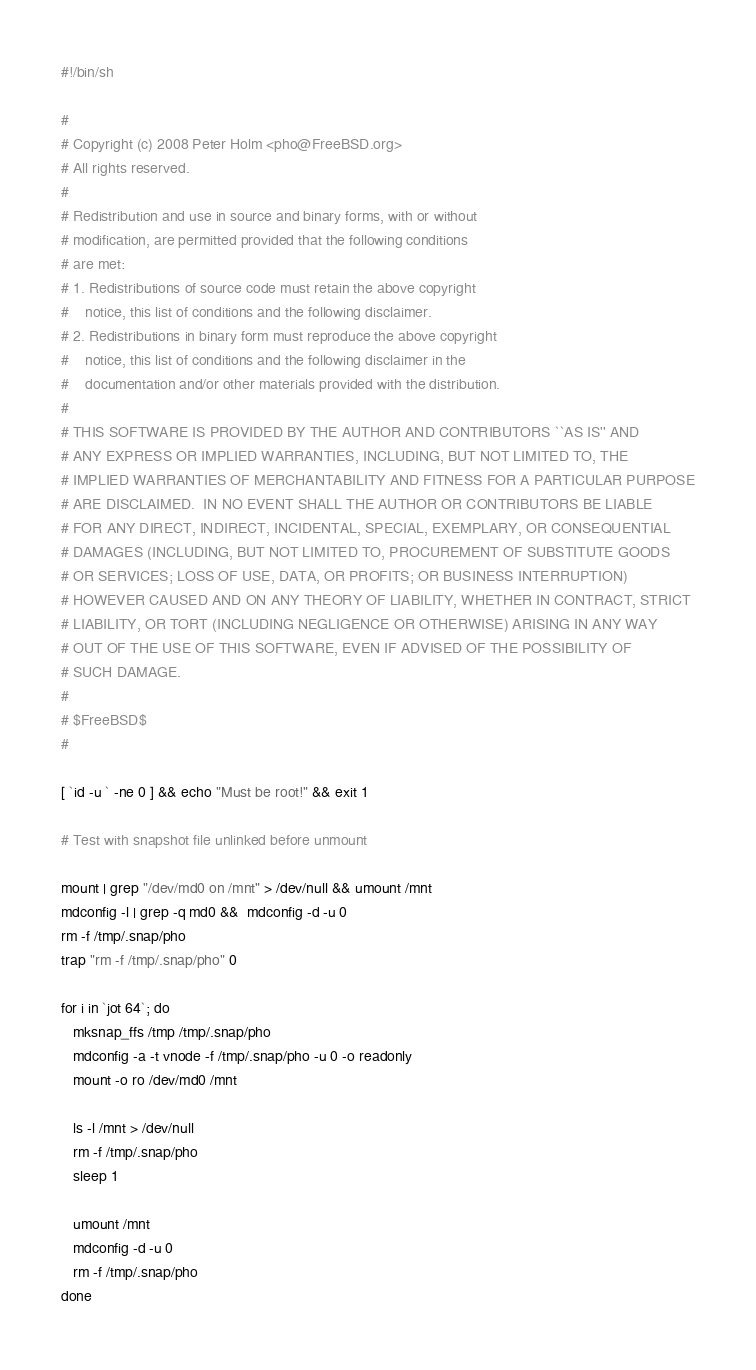Convert code to text. <code><loc_0><loc_0><loc_500><loc_500><_Bash_>#!/bin/sh

#
# Copyright (c) 2008 Peter Holm <pho@FreeBSD.org>
# All rights reserved.
#
# Redistribution and use in source and binary forms, with or without
# modification, are permitted provided that the following conditions
# are met:
# 1. Redistributions of source code must retain the above copyright
#    notice, this list of conditions and the following disclaimer.
# 2. Redistributions in binary form must reproduce the above copyright
#    notice, this list of conditions and the following disclaimer in the
#    documentation and/or other materials provided with the distribution.
#
# THIS SOFTWARE IS PROVIDED BY THE AUTHOR AND CONTRIBUTORS ``AS IS'' AND
# ANY EXPRESS OR IMPLIED WARRANTIES, INCLUDING, BUT NOT LIMITED TO, THE
# IMPLIED WARRANTIES OF MERCHANTABILITY AND FITNESS FOR A PARTICULAR PURPOSE
# ARE DISCLAIMED.  IN NO EVENT SHALL THE AUTHOR OR CONTRIBUTORS BE LIABLE
# FOR ANY DIRECT, INDIRECT, INCIDENTAL, SPECIAL, EXEMPLARY, OR CONSEQUENTIAL
# DAMAGES (INCLUDING, BUT NOT LIMITED TO, PROCUREMENT OF SUBSTITUTE GOODS
# OR SERVICES; LOSS OF USE, DATA, OR PROFITS; OR BUSINESS INTERRUPTION)
# HOWEVER CAUSED AND ON ANY THEORY OF LIABILITY, WHETHER IN CONTRACT, STRICT
# LIABILITY, OR TORT (INCLUDING NEGLIGENCE OR OTHERWISE) ARISING IN ANY WAY
# OUT OF THE USE OF THIS SOFTWARE, EVEN IF ADVISED OF THE POSSIBILITY OF
# SUCH DAMAGE.
#
# $FreeBSD$
#

[ `id -u ` -ne 0 ] && echo "Must be root!" && exit 1

# Test with snapshot file unlinked before unmount

mount | grep "/dev/md0 on /mnt" > /dev/null && umount /mnt
mdconfig -l | grep -q md0 &&  mdconfig -d -u 0
rm -f /tmp/.snap/pho
trap "rm -f /tmp/.snap/pho" 0

for i in `jot 64`; do
   mksnap_ffs /tmp /tmp/.snap/pho
   mdconfig -a -t vnode -f /tmp/.snap/pho -u 0 -o readonly
   mount -o ro /dev/md0 /mnt

   ls -l /mnt > /dev/null
   rm -f /tmp/.snap/pho
   sleep 1

   umount /mnt
   mdconfig -d -u 0
   rm -f /tmp/.snap/pho
done
</code> 